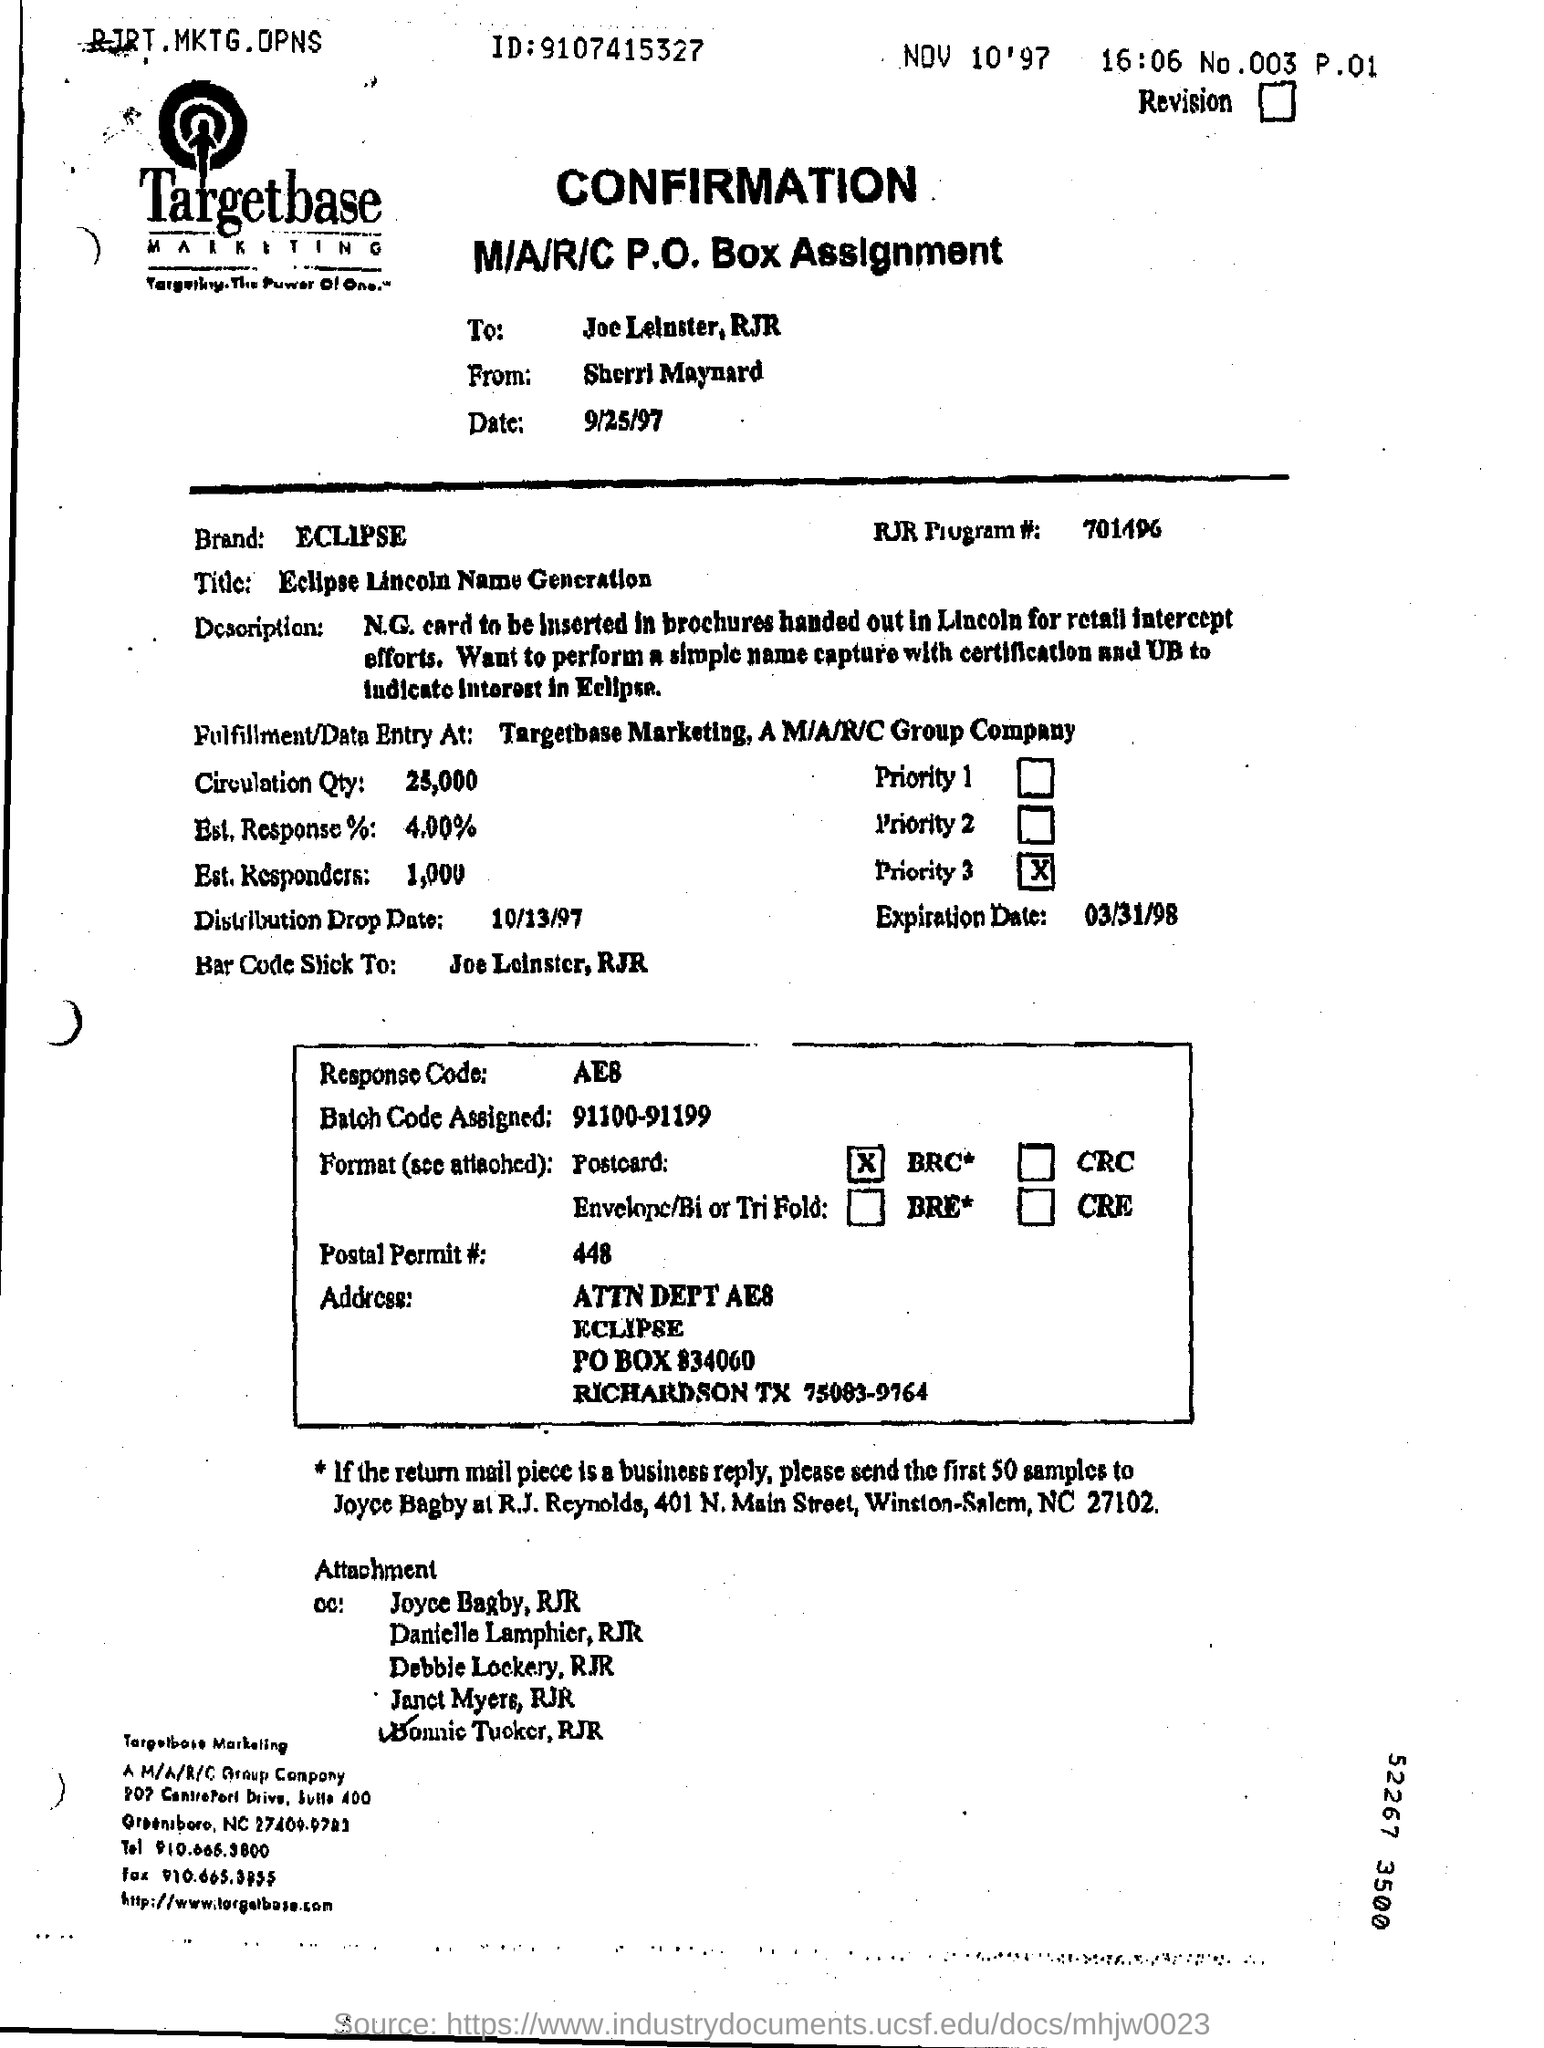Identify some key points in this picture. The document is addressed to Joe Leinster. The RJR Program # is 701496... The confirmation form is being sent by Sherri Maynard. 